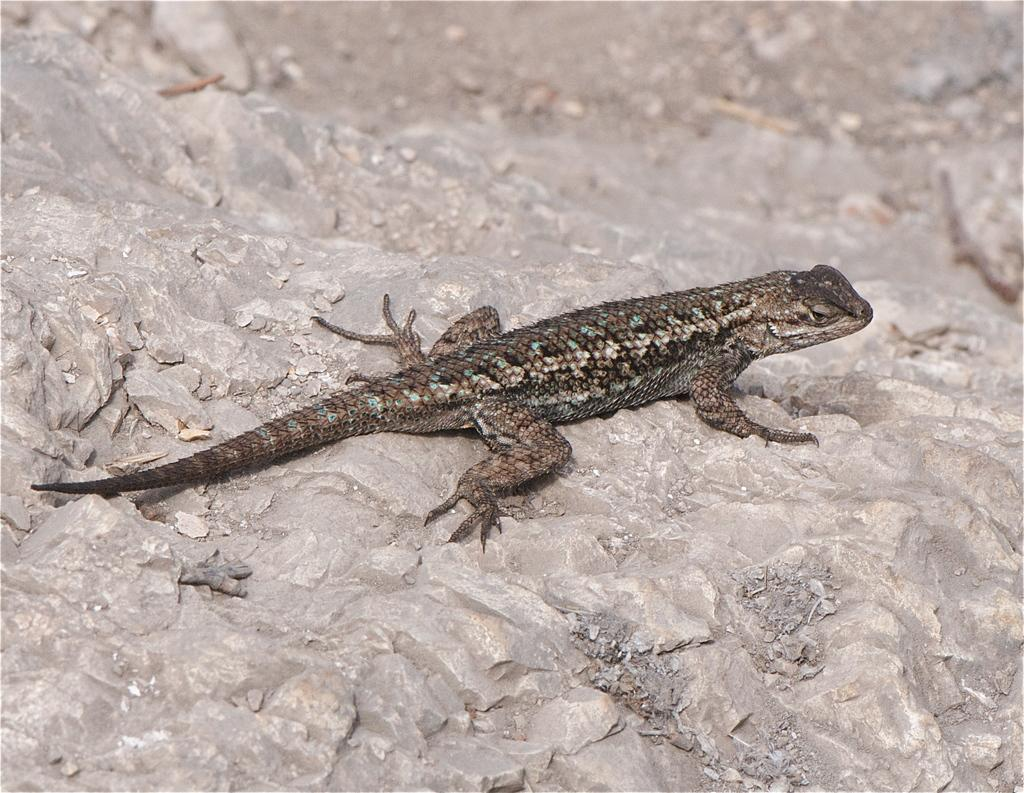What type of animal is in the image? There is a reptile in the image. Where is the reptile located? The reptile is on a rock. In which direction is the reptile facing? The reptile is facing towards the right side. What type of payment is the reptile making in the image? There is no payment being made in the image; it features a reptile on a rock facing towards the right side. 